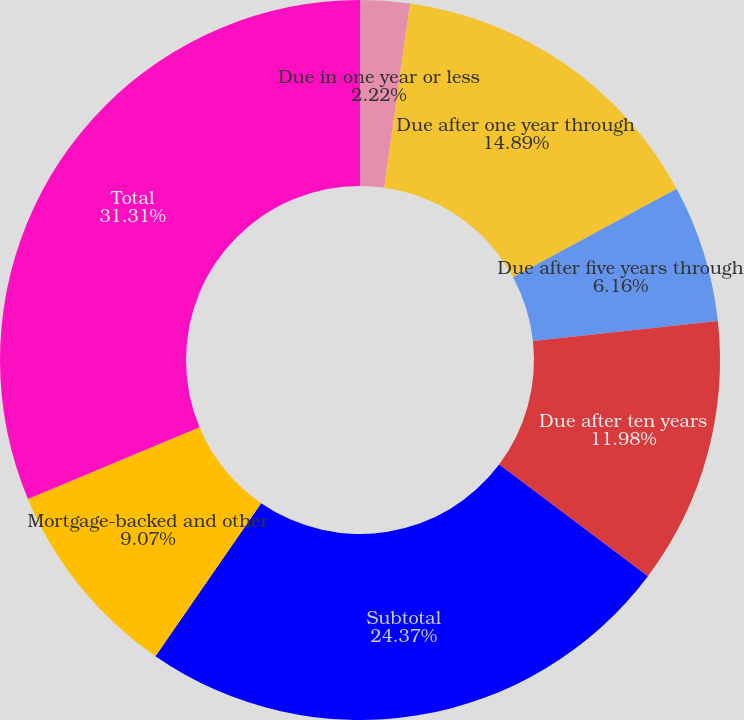Convert chart. <chart><loc_0><loc_0><loc_500><loc_500><pie_chart><fcel>Due in one year or less<fcel>Due after one year through<fcel>Due after five years through<fcel>Due after ten years<fcel>Subtotal<fcel>Mortgage-backed and other<fcel>Total<nl><fcel>2.22%<fcel>14.89%<fcel>6.16%<fcel>11.98%<fcel>24.37%<fcel>9.07%<fcel>31.31%<nl></chart> 